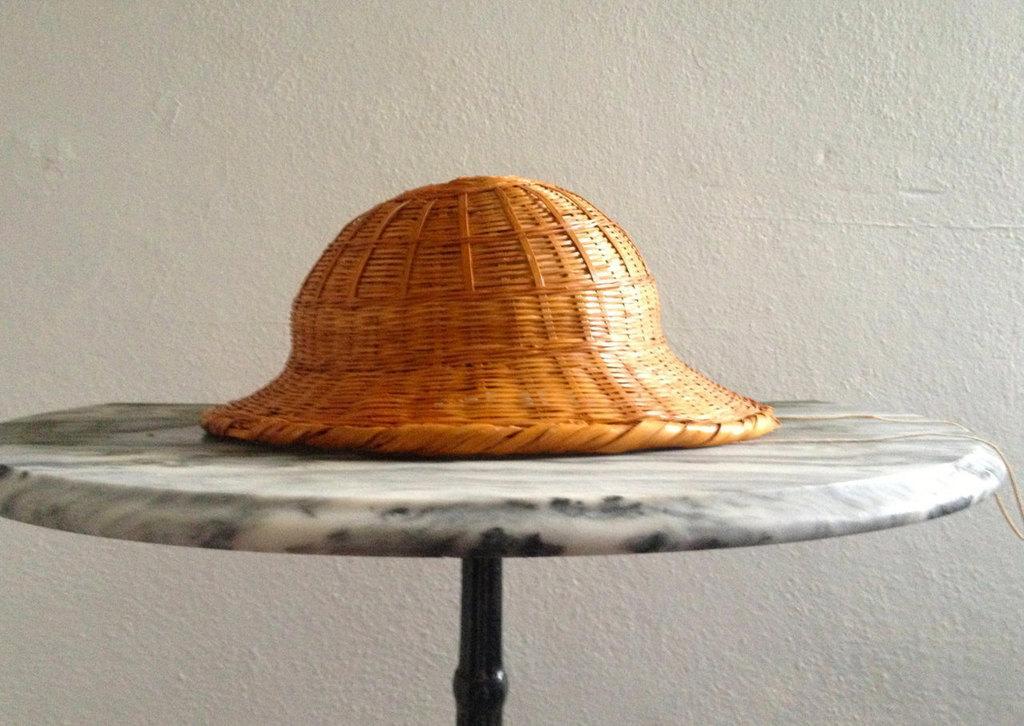How would you summarize this image in a sentence or two? In this picture there is a hat on the table. At the back there is a wall. 